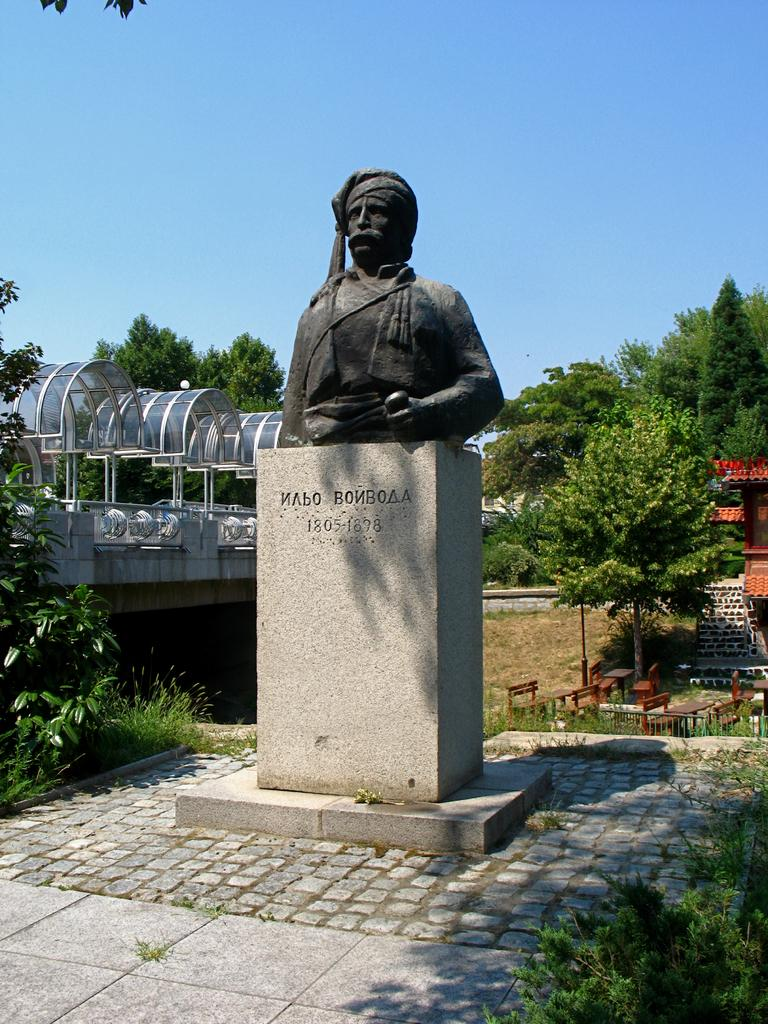What is the main subject in the image? There is a statue in the image. What can be seen in the background of the image? There are trees, benches, houses, and a pole in the background of the image. How does the frog contribute to the scene in the image? There is no frog present in the image. What type of loss is depicted in the image? There is no loss depicted in the image; it features a statue and various background elements. 